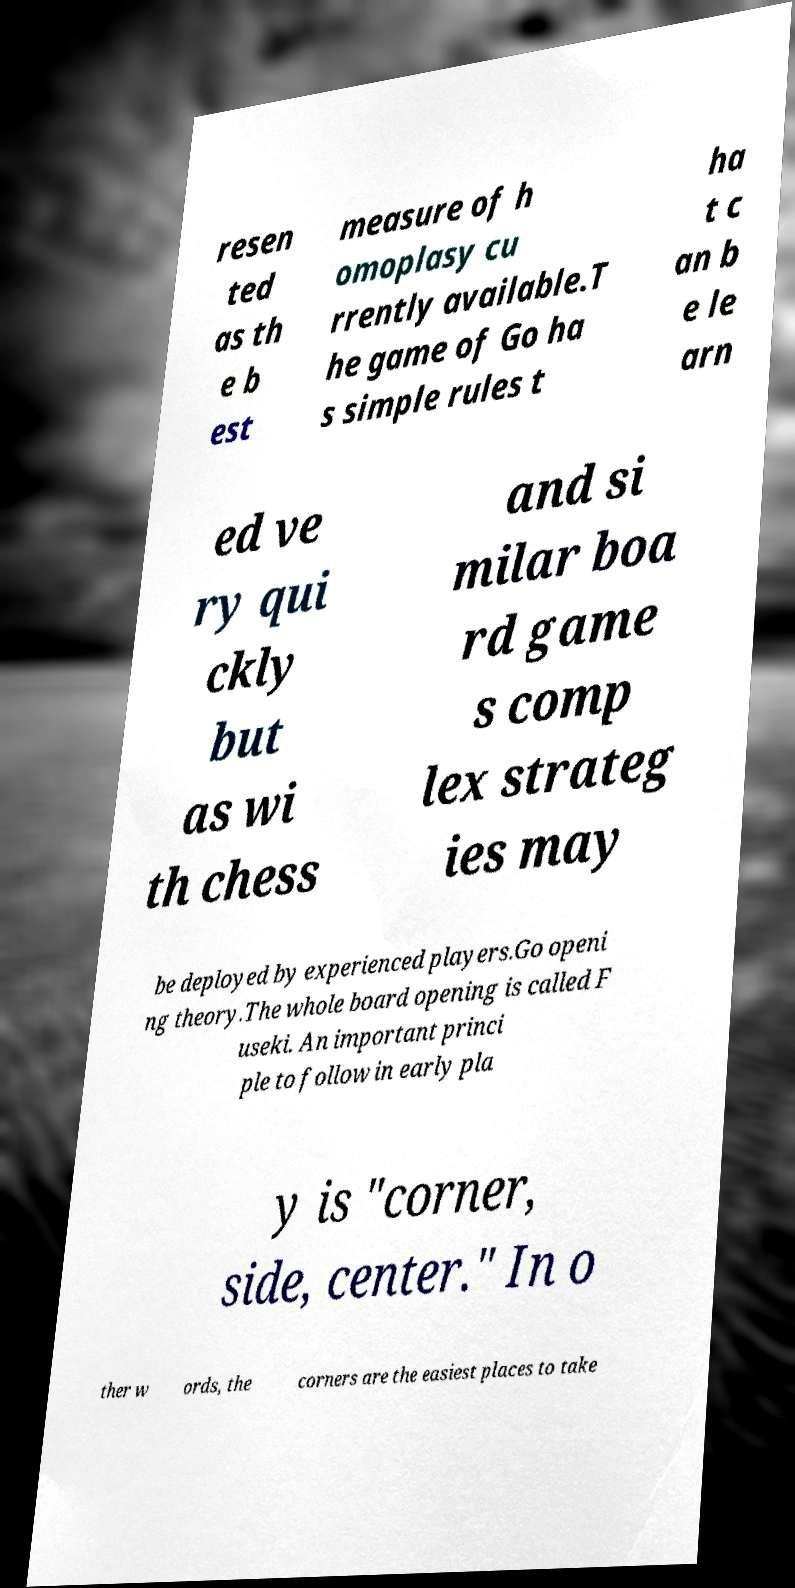I need the written content from this picture converted into text. Can you do that? resen ted as th e b est measure of h omoplasy cu rrently available.T he game of Go ha s simple rules t ha t c an b e le arn ed ve ry qui ckly but as wi th chess and si milar boa rd game s comp lex strateg ies may be deployed by experienced players.Go openi ng theory.The whole board opening is called F useki. An important princi ple to follow in early pla y is "corner, side, center." In o ther w ords, the corners are the easiest places to take 